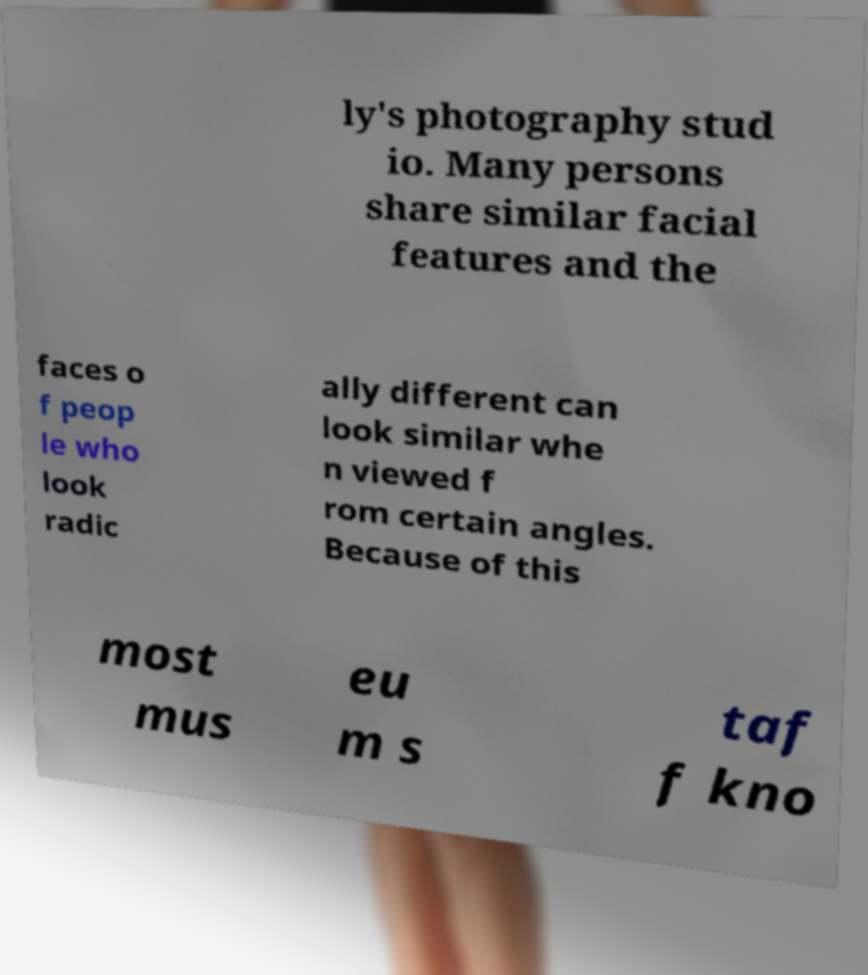There's text embedded in this image that I need extracted. Can you transcribe it verbatim? ly's photography stud io. Many persons share similar facial features and the faces o f peop le who look radic ally different can look similar whe n viewed f rom certain angles. Because of this most mus eu m s taf f kno 